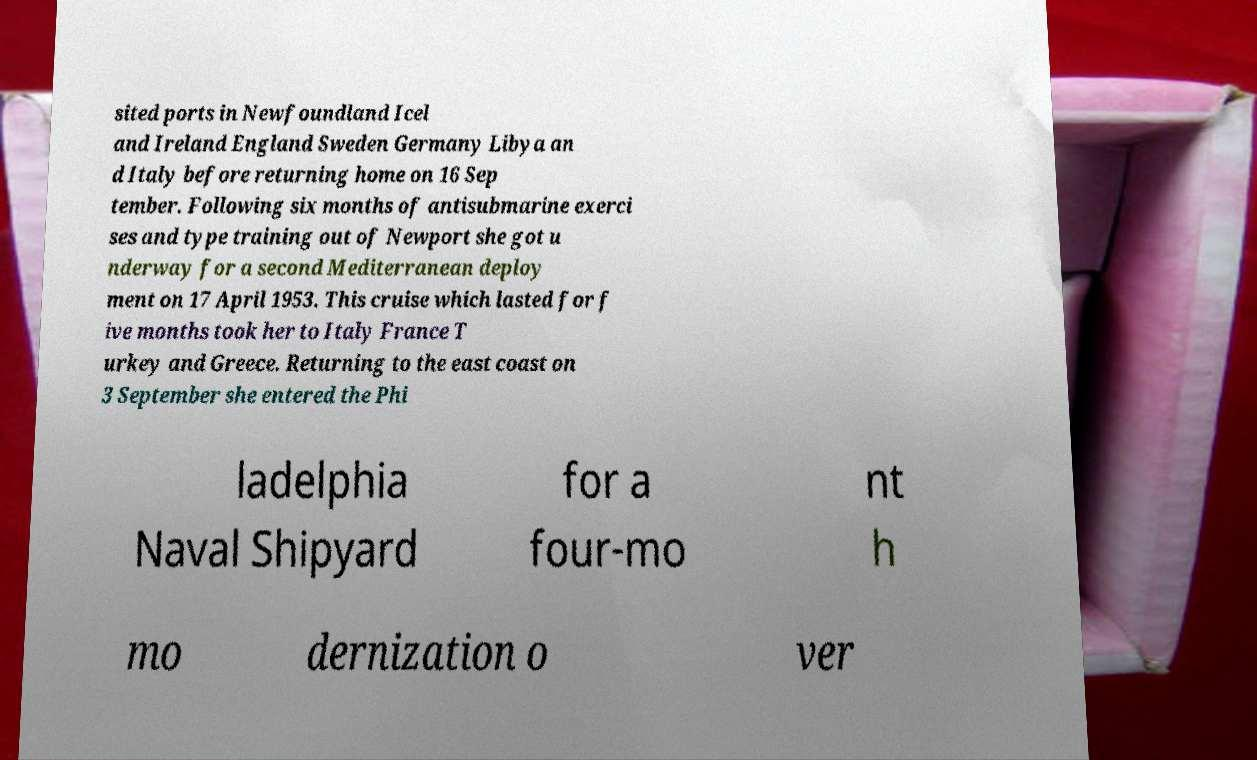Could you extract and type out the text from this image? sited ports in Newfoundland Icel and Ireland England Sweden Germany Libya an d Italy before returning home on 16 Sep tember. Following six months of antisubmarine exerci ses and type training out of Newport she got u nderway for a second Mediterranean deploy ment on 17 April 1953. This cruise which lasted for f ive months took her to Italy France T urkey and Greece. Returning to the east coast on 3 September she entered the Phi ladelphia Naval Shipyard for a four-mo nt h mo dernization o ver 